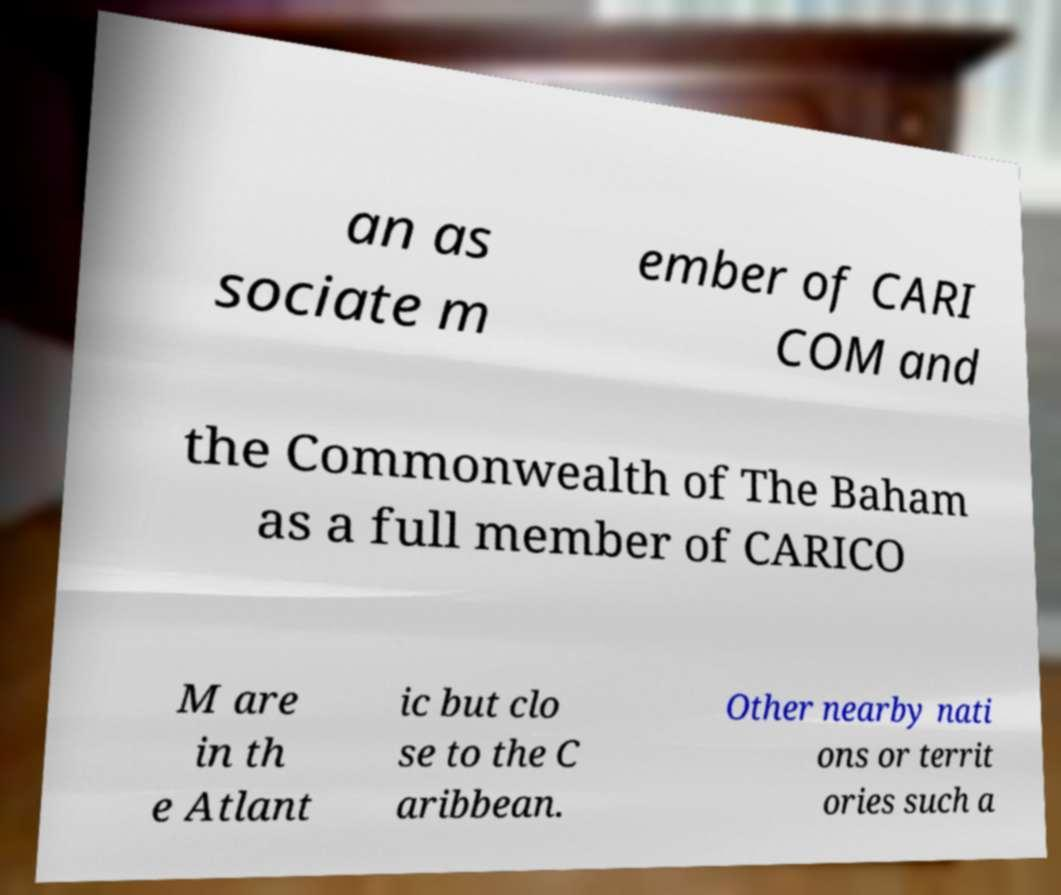I need the written content from this picture converted into text. Can you do that? an as sociate m ember of CARI COM and the Commonwealth of The Baham as a full member of CARICO M are in th e Atlant ic but clo se to the C aribbean. Other nearby nati ons or territ ories such a 